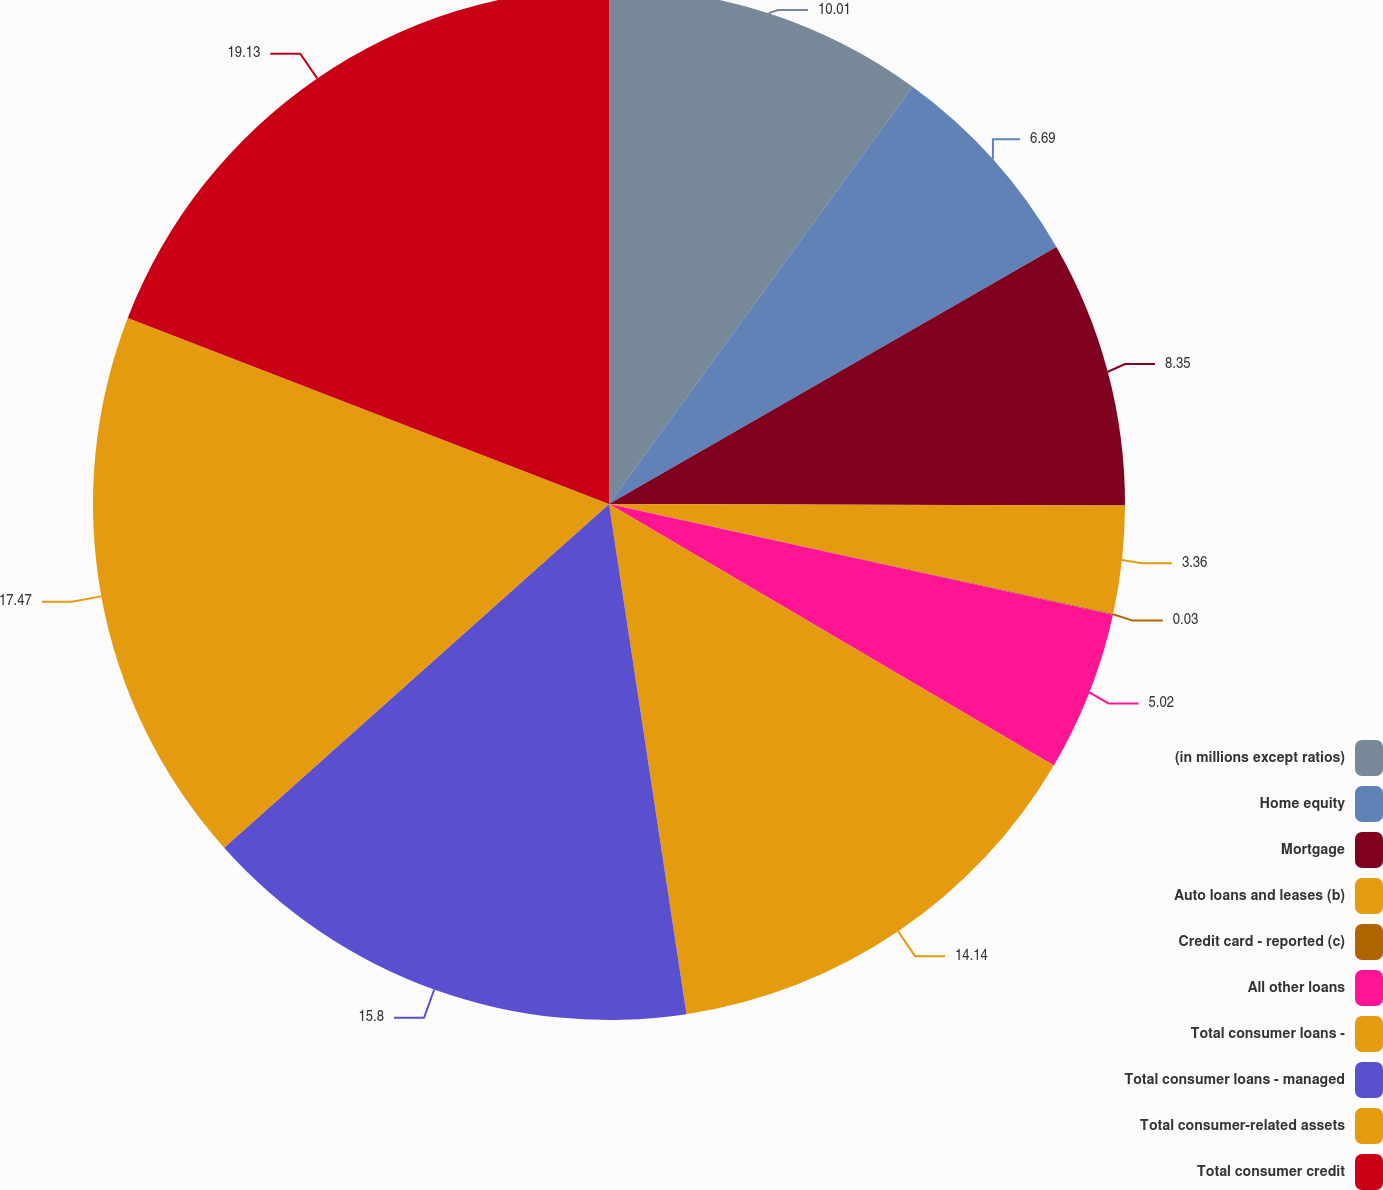Convert chart. <chart><loc_0><loc_0><loc_500><loc_500><pie_chart><fcel>(in millions except ratios)<fcel>Home equity<fcel>Mortgage<fcel>Auto loans and leases (b)<fcel>Credit card - reported (c)<fcel>All other loans<fcel>Total consumer loans -<fcel>Total consumer loans - managed<fcel>Total consumer-related assets<fcel>Total consumer credit<nl><fcel>10.01%<fcel>6.69%<fcel>8.35%<fcel>3.36%<fcel>0.03%<fcel>5.02%<fcel>14.14%<fcel>15.8%<fcel>17.47%<fcel>19.13%<nl></chart> 